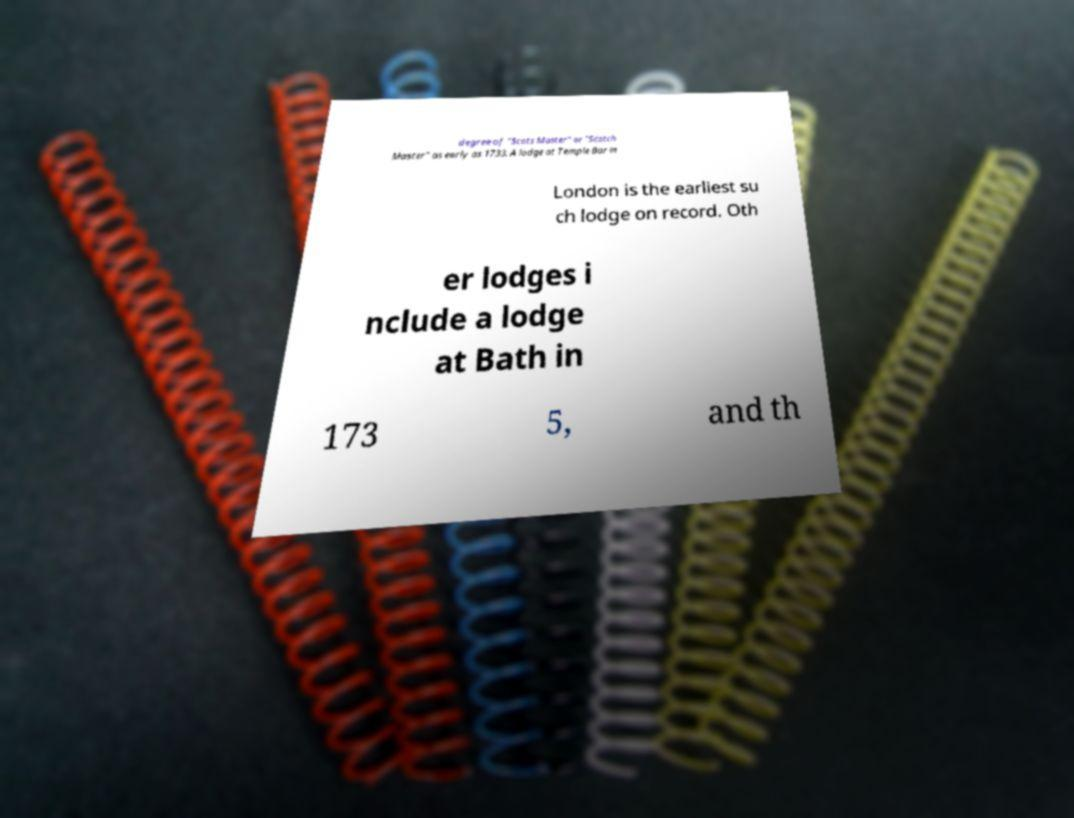I need the written content from this picture converted into text. Can you do that? degree of "Scots Master" or "Scotch Master" as early as 1733. A lodge at Temple Bar in London is the earliest su ch lodge on record. Oth er lodges i nclude a lodge at Bath in 173 5, and th 